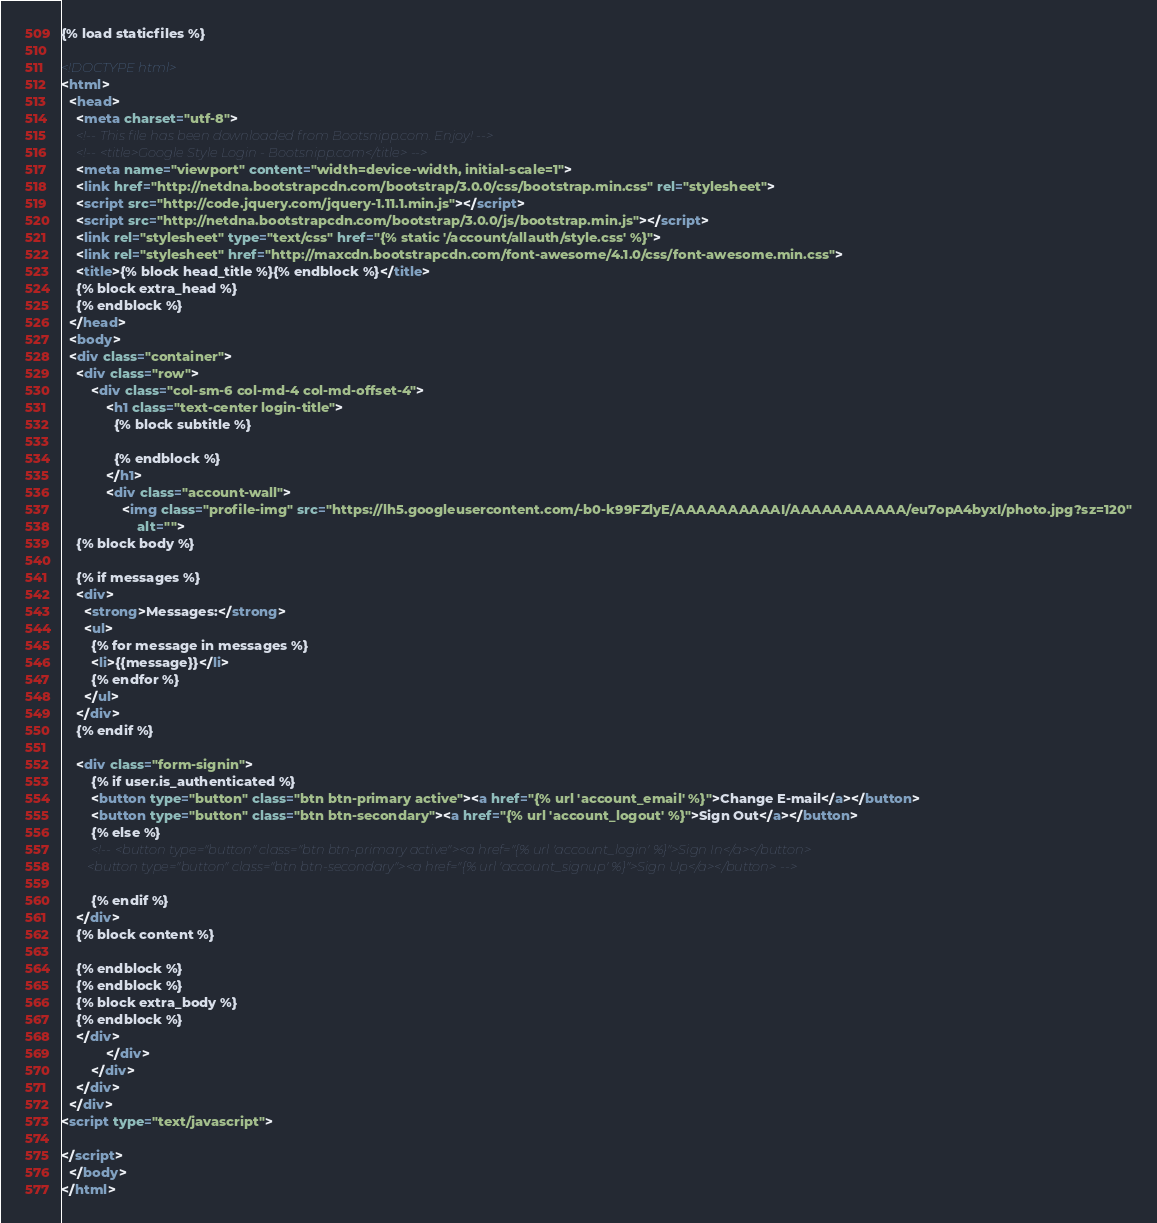<code> <loc_0><loc_0><loc_500><loc_500><_HTML_>{% load staticfiles %}

<!DOCTYPE html>
<html>
  <head>
    <meta charset="utf-8">
    <!-- This file has been downloaded from Bootsnipp.com. Enjoy! -->
    <!-- <title>Google Style Login - Bootsnipp.com</title> -->
    <meta name="viewport" content="width=device-width, initial-scale=1">
    <link href="http://netdna.bootstrapcdn.com/bootstrap/3.0.0/css/bootstrap.min.css" rel="stylesheet">
    <script src="http://code.jquery.com/jquery-1.11.1.min.js"></script>
    <script src="http://netdna.bootstrapcdn.com/bootstrap/3.0.0/js/bootstrap.min.js"></script>
    <link rel="stylesheet" type="text/css" href="{% static '/account/allauth/style.css' %}">
    <link rel="stylesheet" href="http://maxcdn.bootstrapcdn.com/font-awesome/4.1.0/css/font-awesome.min.css">
    <title>{% block head_title %}{% endblock %}</title>
    {% block extra_head %}
    {% endblock %}
  </head>
  <body>
  <div class="container">
    <div class="row">
        <div class="col-sm-6 col-md-4 col-md-offset-4">
            <h1 class="text-center login-title">
              {% block subtitle %}

              {% endblock %}
            </h1>
            <div class="account-wall">
                <img class="profile-img" src="https://lh5.googleusercontent.com/-b0-k99FZlyE/AAAAAAAAAAI/AAAAAAAAAAA/eu7opA4byxI/photo.jpg?sz=120"
                    alt="">
    {% block body %}

    {% if messages %}
    <div>
      <strong>Messages:</strong>
      <ul>
        {% for message in messages %}
        <li>{{message}}</li>
        {% endfor %}
      </ul>
    </div>
    {% endif %}

    <div class="form-signin">
        {% if user.is_authenticated %}
        <button type="button" class="btn btn-primary active"><a href="{% url 'account_email' %}">Change E-mail</a></button>
        <button type="button" class="btn btn-secondary"><a href="{% url 'account_logout' %}">Sign Out</a></button>
        {% else %}
        <!-- <button type="button" class="btn btn-primary active"><a href="{% url 'account_login' %}">Sign In</a></button>
        <button type="button" class="btn btn-secondary"><a href="{% url 'account_signup' %}">Sign Up</a></button> -->

        {% endif %}
    </div>
    {% block content %}

    {% endblock %}
    {% endblock %}
    {% block extra_body %}
    {% endblock %}
    </div>
            </div>
        </div>
    </div>
  </div>
<script type="text/javascript">

</script>
  </body>
</html>
</code> 